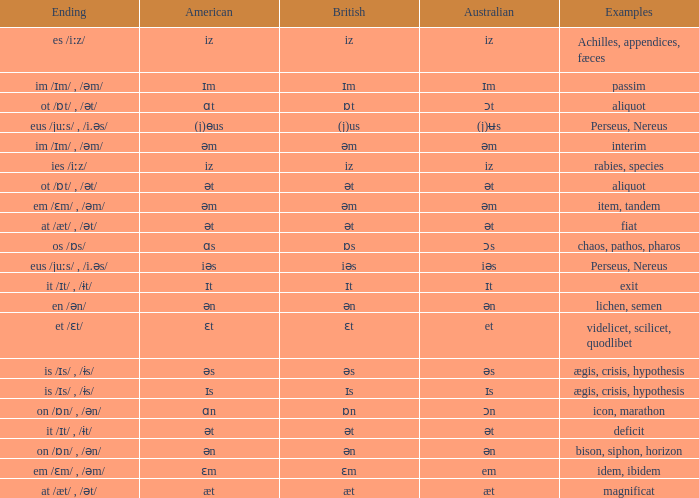Which British has Examples of exit? Ɪt. 